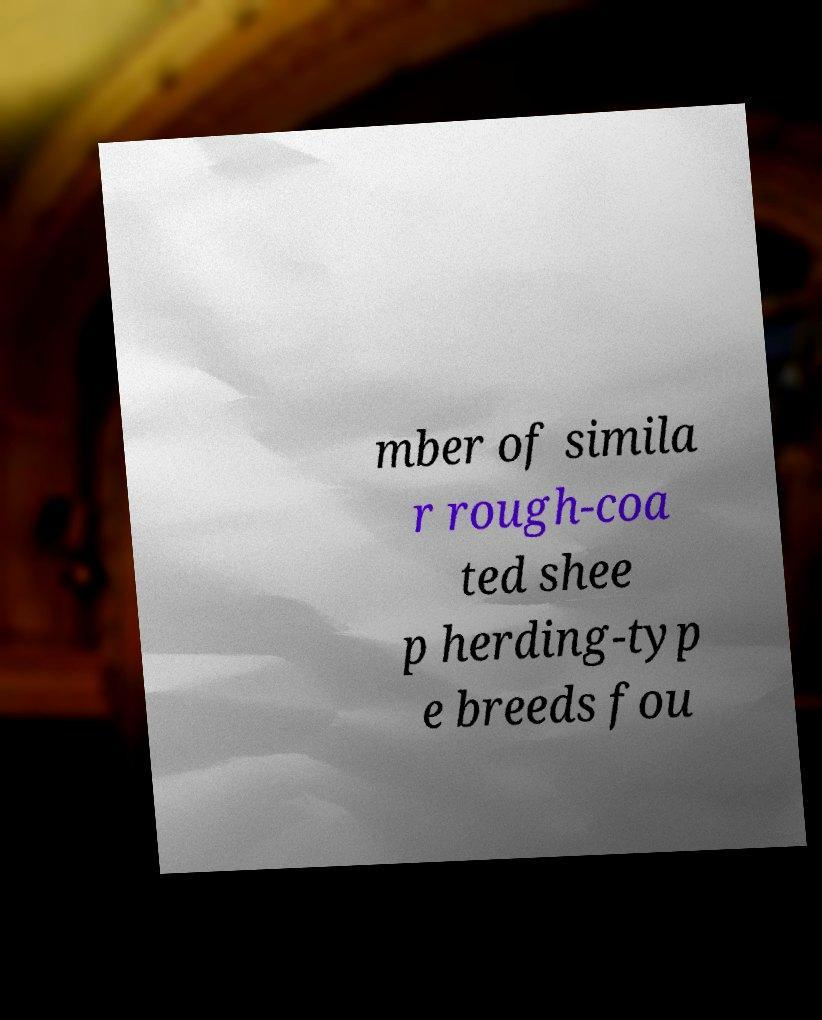What messages or text are displayed in this image? I need them in a readable, typed format. mber of simila r rough-coa ted shee p herding-typ e breeds fou 